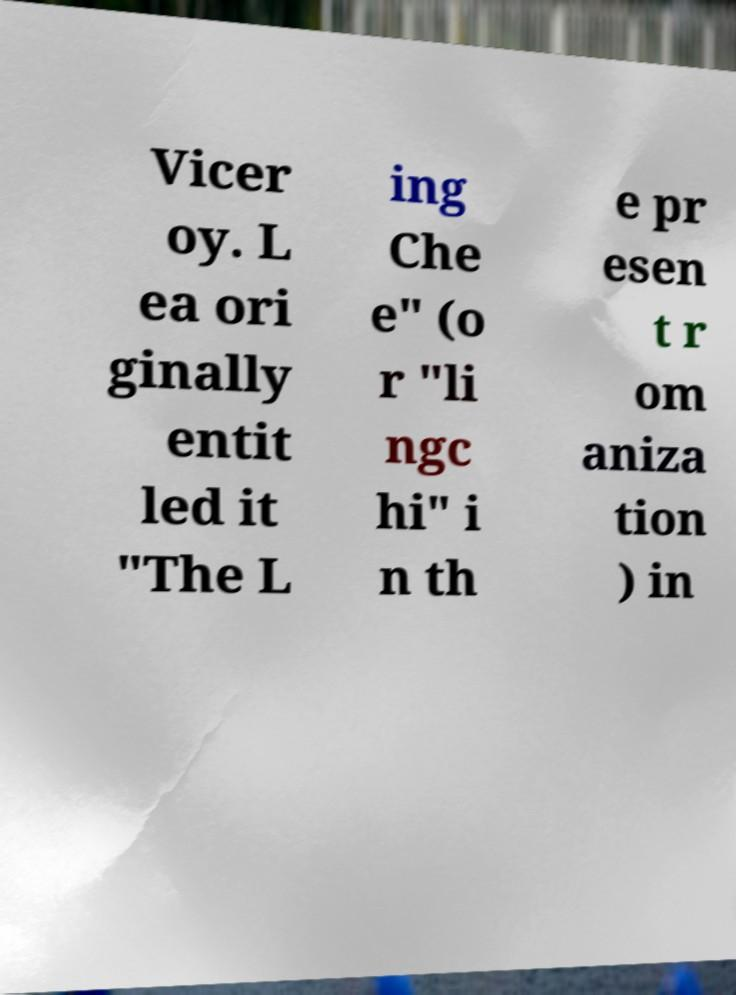Can you read and provide the text displayed in the image?This photo seems to have some interesting text. Can you extract and type it out for me? Vicer oy. L ea ori ginally entit led it "The L ing Che e" (o r "li ngc hi" i n th e pr esen t r om aniza tion ) in 